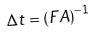Convert formula to latex. <formula><loc_0><loc_0><loc_500><loc_500>\Delta t = ( F A ) ^ { - 1 }</formula> 